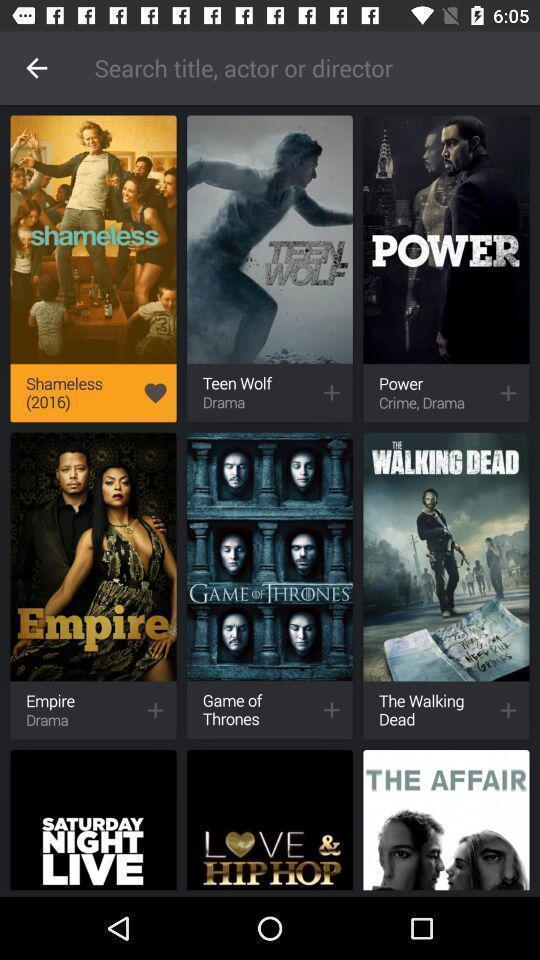Provide a description of this screenshot. Search page in an online streaming movie app. 